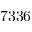<formula> <loc_0><loc_0><loc_500><loc_500>7 3 3 6</formula> 